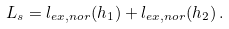<formula> <loc_0><loc_0><loc_500><loc_500>L _ { s } = l _ { e x , n o r } ( h _ { 1 } ) + l _ { e x , n o r } ( h _ { 2 } ) \, .</formula> 